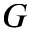<formula> <loc_0><loc_0><loc_500><loc_500>G</formula> 